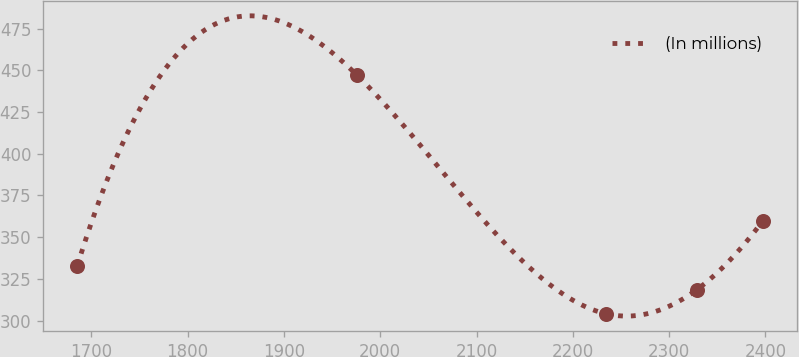Convert chart. <chart><loc_0><loc_0><loc_500><loc_500><line_chart><ecel><fcel>(In millions)<nl><fcel>1685.35<fcel>332.76<nl><fcel>1975.58<fcel>447.28<nl><fcel>2233.96<fcel>304.12<nl><fcel>2328.7<fcel>318.44<nl><fcel>2397.58<fcel>359.96<nl></chart> 